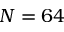Convert formula to latex. <formula><loc_0><loc_0><loc_500><loc_500>N = 6 4</formula> 